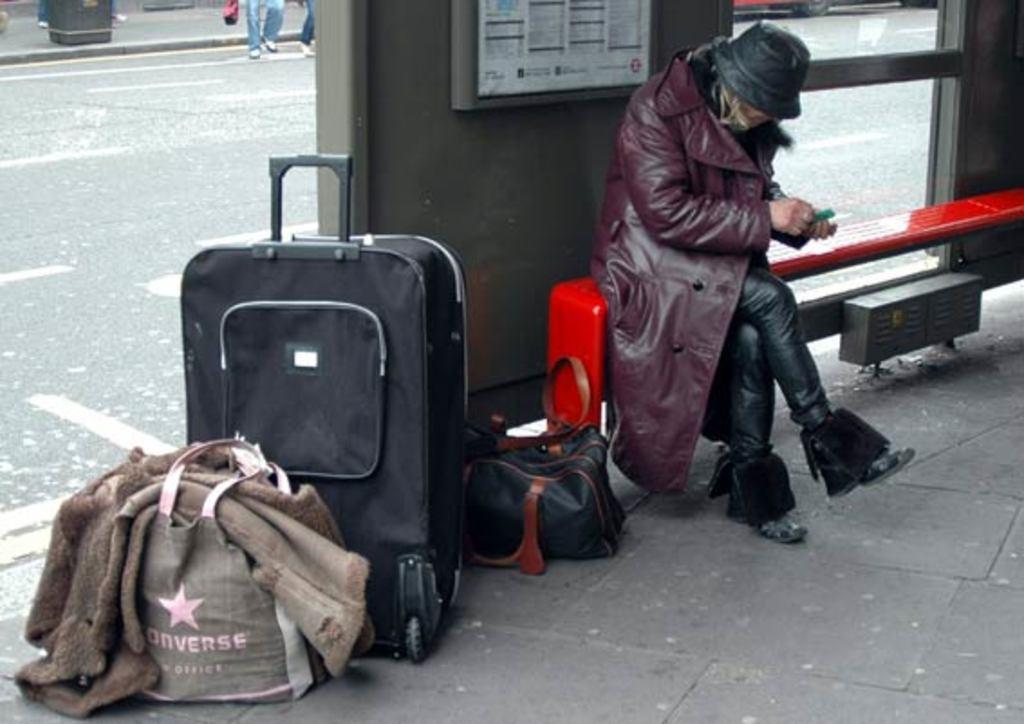Can you describe this image briefly? In the image we can see one man sitting on the bench. Beside him we can see trolley,bag,jacket and one more bag. And he is wearing cap. And back we can see road and few persons were standing and pillar. 